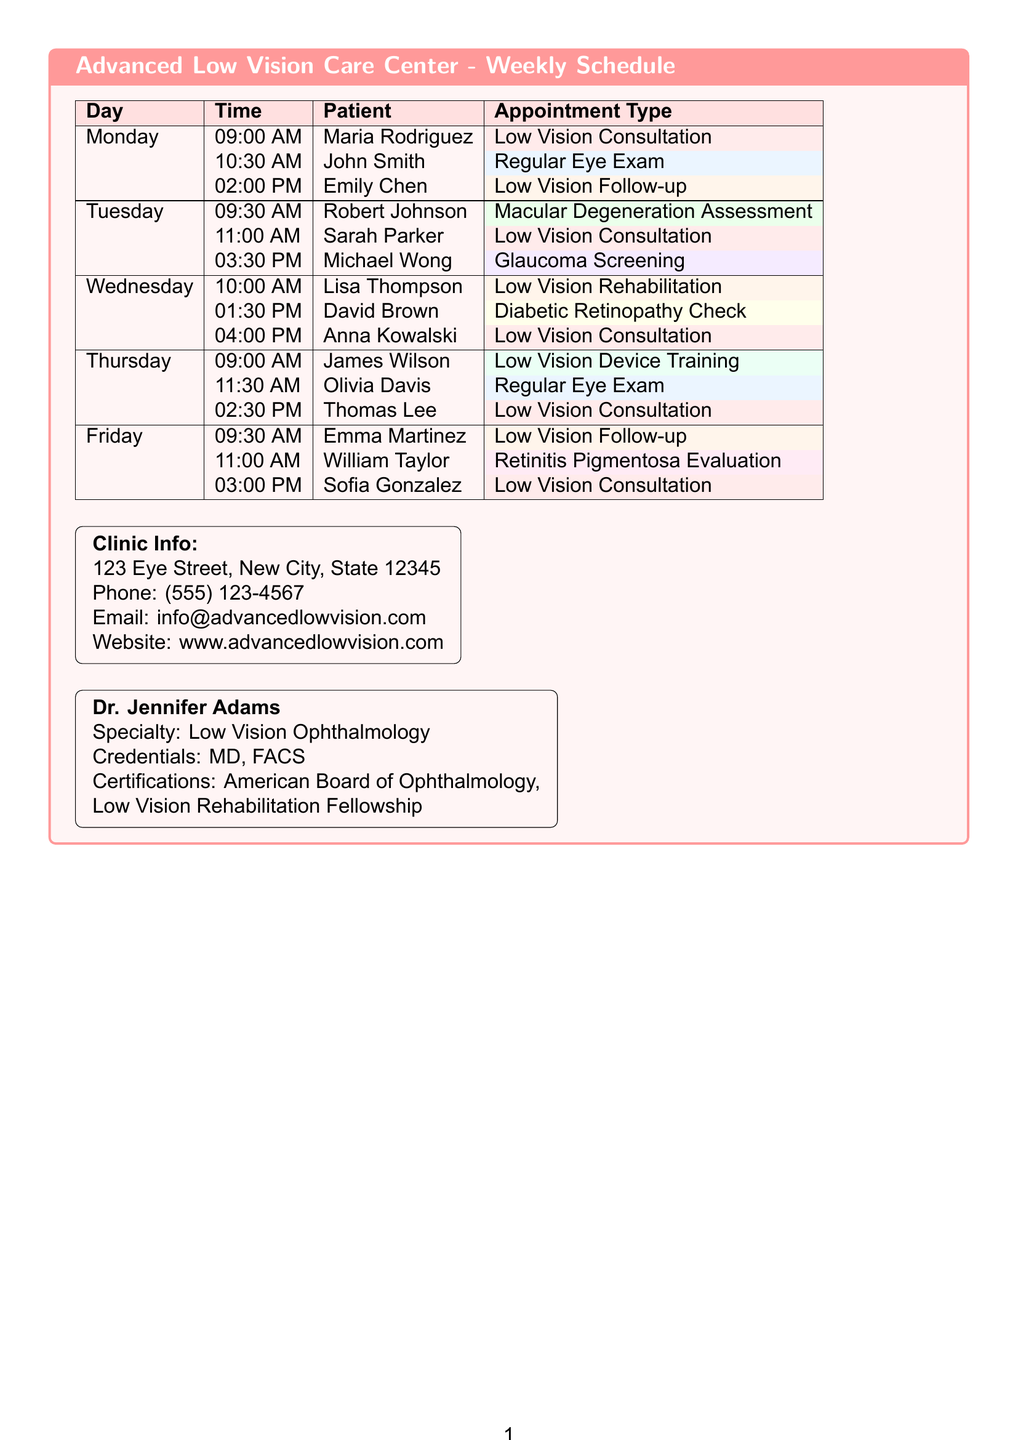what is the name of the clinic? The name of the clinic is mentioned at the beginning of the document, indicating the facility providing the services.
Answer: Advanced Low Vision Care Center who is the doctor specializing in low vision? The document provides the name of the doctor along with their specialty at the end section, showcasing the clinical staff.
Answer: Dr. Jennifer Adams how many low vision consultations are scheduled on Monday? By reviewing the Monday schedule slots, one can count the number of appointments categorized as low vision consultations.
Answer: 2 what is the time of Sarah Parker's appointment? The document outlines the schedule by day and time, specifically indicating all appointments for each patient.
Answer: 11:00 AM which appointment type is scheduled for 03:00 PM on Friday? The schedule lists the type of appointment associated with specific time slots on that day, allowing for quick identification.
Answer: Low Vision Consultation how many total low vision follow-up appointments are there this week? Counting the number of slots designated for low vision follow-ups throughout the week provides the answer required.
Answer: 3 what color code is used for low vision consultations? The document specifies color codes connected with each type of appointment, making it simple to identify them visually.
Answer: #FF9999 what type of appointment is scheduled for 09:00 AM on Thursday? The specific time slot can be referenced directly from the schedule, detailing which patient and their corresponding appointment type.
Answer: Low Vision Device Training 